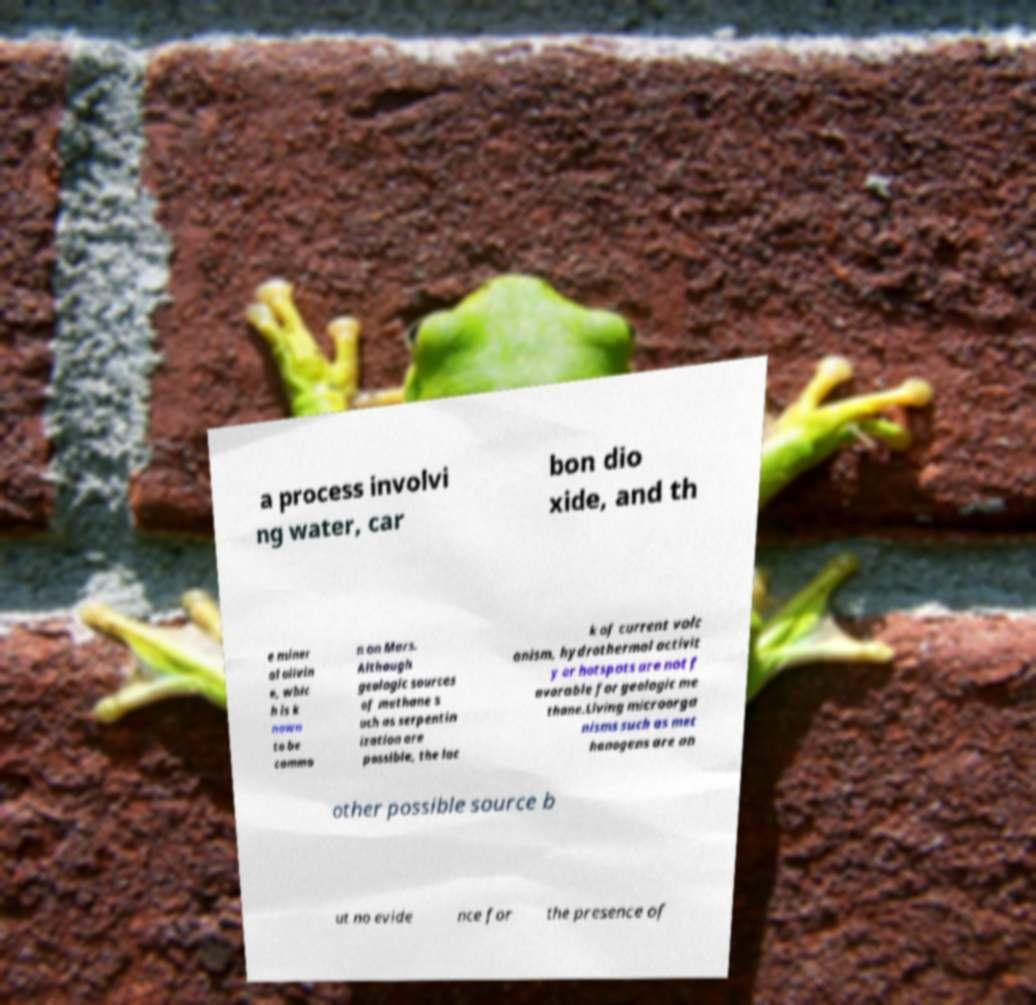There's text embedded in this image that I need extracted. Can you transcribe it verbatim? a process involvi ng water, car bon dio xide, and th e miner al olivin e, whic h is k nown to be commo n on Mars. Although geologic sources of methane s uch as serpentin ization are possible, the lac k of current volc anism, hydrothermal activit y or hotspots are not f avorable for geologic me thane.Living microorga nisms such as met hanogens are an other possible source b ut no evide nce for the presence of 